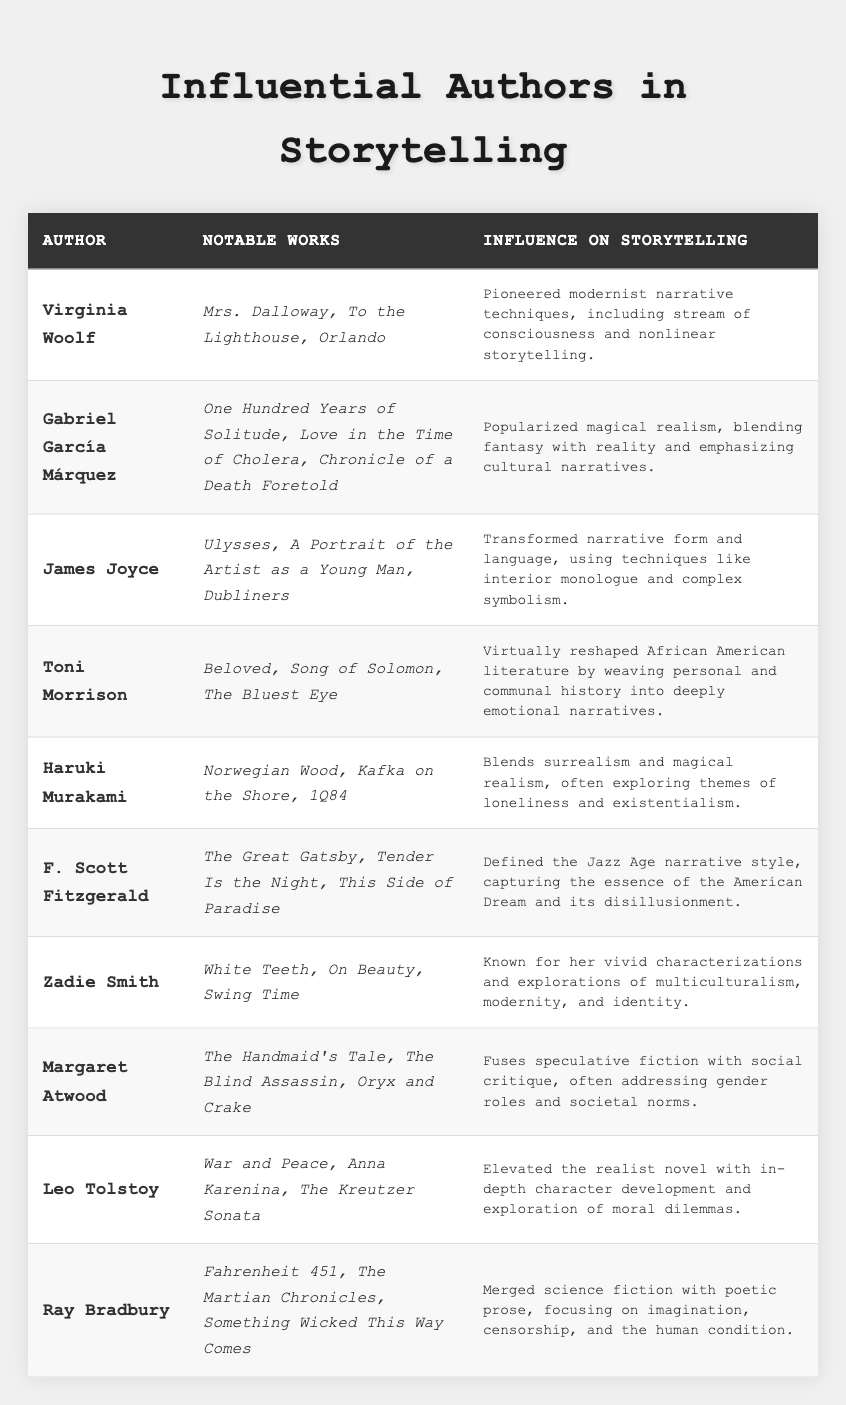What notable work is associated with Virginia Woolf? According to the table, notable works associated with Virginia Woolf include "Mrs. Dalloway," "To the Lighthouse," and "Orlando."
Answer: Mrs. Dalloway, To the Lighthouse, Orlando Which author is known for blending magical realism in their storytelling? From the table, Gabriel García Márquez is recognized for popularizing magical realism, blending fantasy with reality.
Answer: Gabriel García Márquez Did F. Scott Fitzgerald write "War and Peace"? The table indicates that "War and Peace" is a work of Leo Tolstoy, not F. Scott Fitzgerald.
Answer: No How many authors in the table are associated with the theme of loneliness? Haruki Murakami is noted in the table for exploring themes of loneliness in his works, but no other authors mention this theme specifically. Thus, there is 1 author.
Answer: 1 Which author has reshaped African American literature? The table states that Toni Morrison has virtually reshaped African American literature through her emotional narratives that connect personal and communal history.
Answer: Toni Morrison What is the influence on storytelling for Leo Tolstoy? The table mentions that Leo Tolstoy elevated the realist novel with character development and moral dilemmas, indicating his significant influence on storytelling.
Answer: Elevated the realist novel What notable works are listed for Ray Bradbury? The table specifies that the notable works of Ray Bradbury include "Fahrenheit 451," "The Martian Chronicles," and "Something Wicked This Way Comes."
Answer: Fahrenheit 451, The Martian Chronicles, Something Wicked This Way Comes Which author is paired with the storytelling technique of interior monologue? According to the table, James Joyce is associated with the storytelling technique of interior monologue.
Answer: James Joyce Is Zadie Smith recognized for her explorations of identity and multiculturalism? Yes, the table shows that Zadie Smith is known for her explorations of multiculturalism, modernity, and identity in her works.
Answer: Yes What is the summary of the influence on storytelling for Margaret Atwood? The table explains that Margaret Atwood fuses speculative fiction with social critique, particularly addressing gender roles and societal norms, which highlights her unique influence in storytelling.
Answer: Fuses speculative fiction with social critique Who among the authors is noted for capturing the essence of the American Dream? The table indicates that F. Scott Fitzgerald is known for defining the Jazz Age narrative style and capturing the essence of the American Dream and its disillusionment.
Answer: F. Scott Fitzgerald 